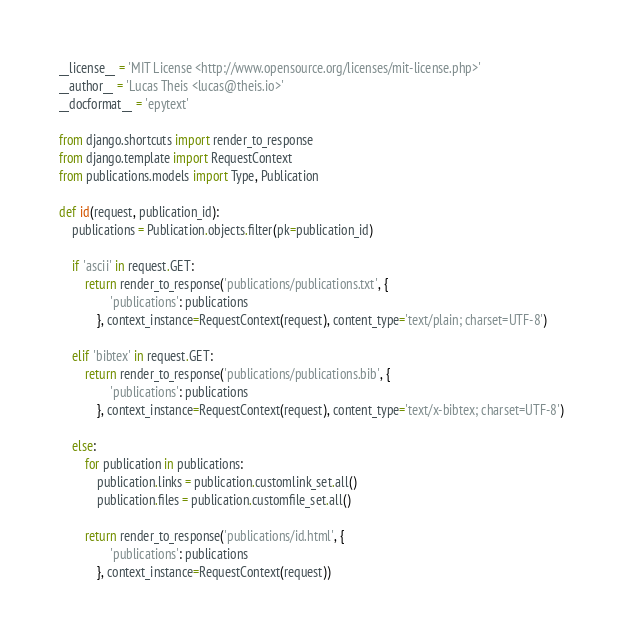Convert code to text. <code><loc_0><loc_0><loc_500><loc_500><_Python_>__license__ = 'MIT License <http://www.opensource.org/licenses/mit-license.php>'
__author__ = 'Lucas Theis <lucas@theis.io>'
__docformat__ = 'epytext'

from django.shortcuts import render_to_response
from django.template import RequestContext
from publications.models import Type, Publication

def id(request, publication_id):
	publications = Publication.objects.filter(pk=publication_id)

	if 'ascii' in request.GET:
		return render_to_response('publications/publications.txt', {
				'publications': publications
			}, context_instance=RequestContext(request), content_type='text/plain; charset=UTF-8')

	elif 'bibtex' in request.GET:
		return render_to_response('publications/publications.bib', {
				'publications': publications
			}, context_instance=RequestContext(request), content_type='text/x-bibtex; charset=UTF-8')

	else:
		for publication in publications:
			publication.links = publication.customlink_set.all()
			publication.files = publication.customfile_set.all()

		return render_to_response('publications/id.html', {
				'publications': publications
			}, context_instance=RequestContext(request))
</code> 